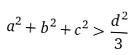Convert formula to latex. <formula><loc_0><loc_0><loc_500><loc_500>a ^ { 2 } + b ^ { 2 } + c ^ { 2 } > \frac { d ^ { 2 } } { 3 }</formula> 